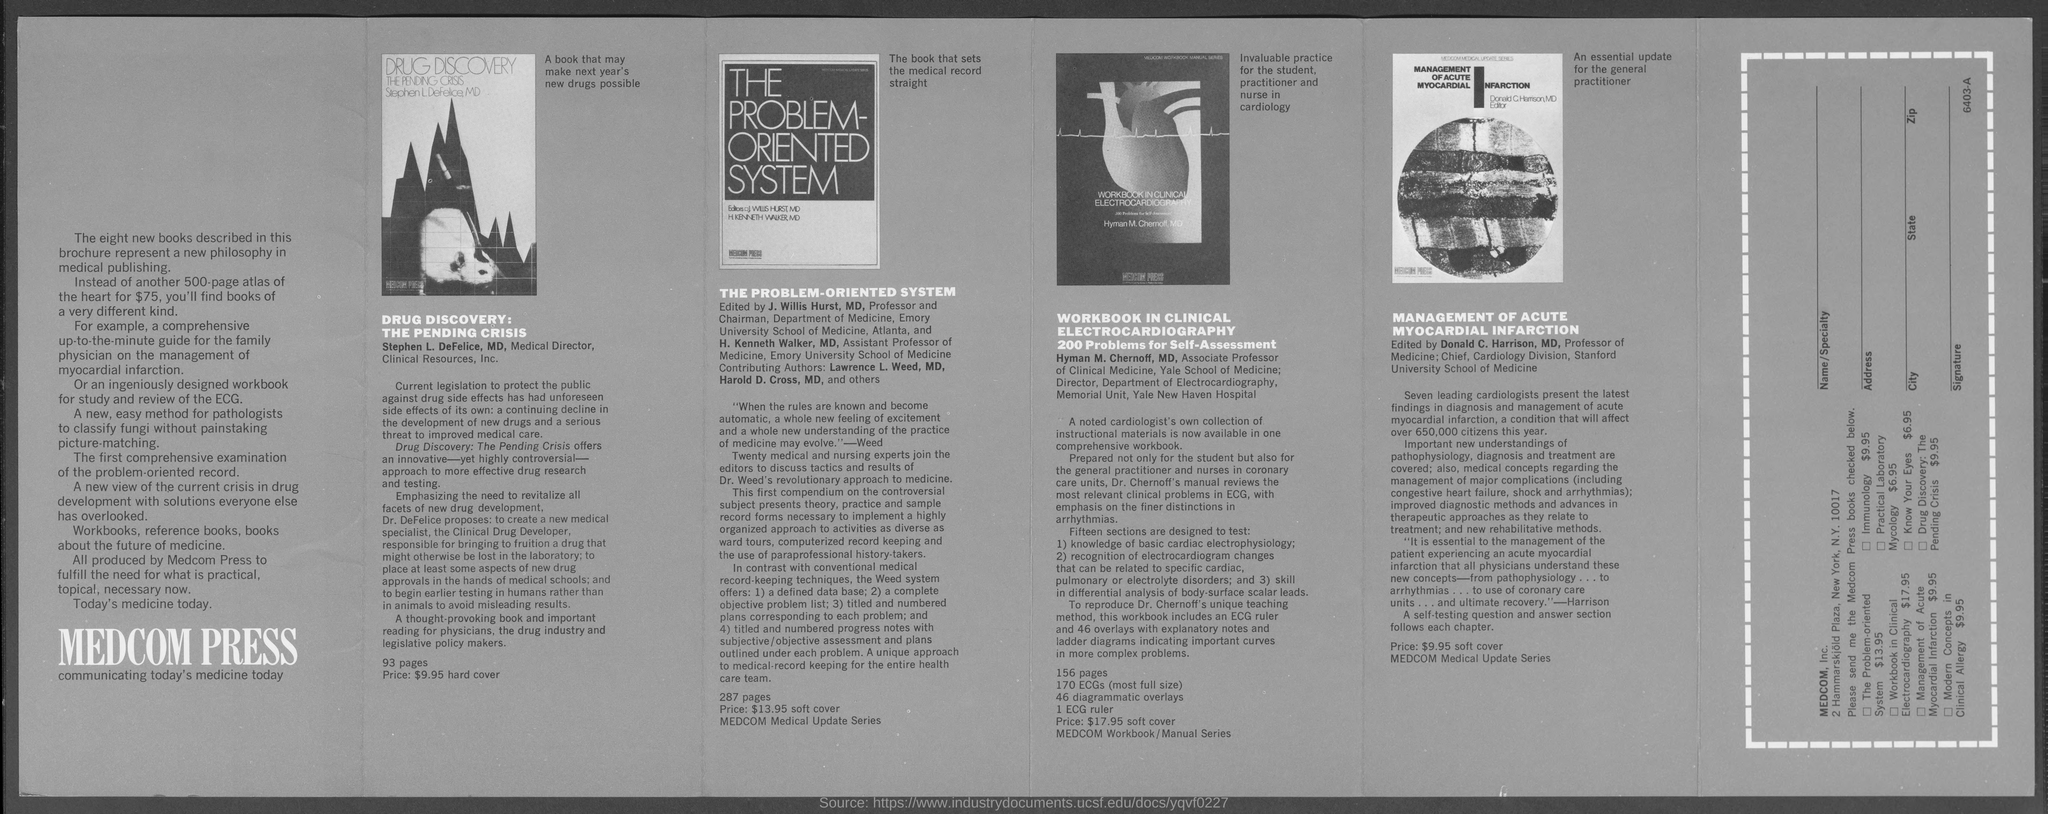Draw attention to some important aspects in this diagram. The author of the "Workbook in Clinical Electrocardiography" is Hyman M. Chernoff, MD. The individual known as the Chief of the Cardiology Division at Stanford University School of Medicine is named Donald C. Harrison. The book 'THE PROBLEM-ORIENTED SYSTEM' is priced at $13.95. The book 'DRUG DISCOVERY: THE PENDING CRISIS' costs $9.95 for a hardcover edition. The author of the book "DRUG DISCOVERY: THE PENDING CRISIS" is Stephen L. DeFelice. 